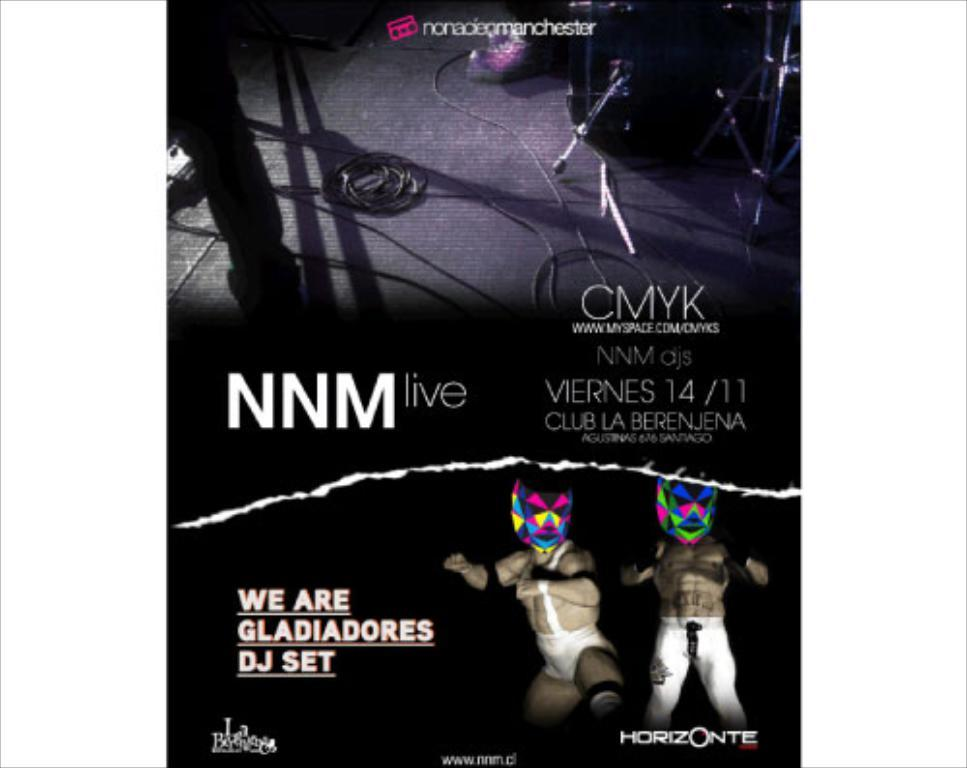What is featured in the picture? There is a poster in the picture. Can you describe the poster? The poster has two persons on the bottom right side. What are the persons on the poster wearing on their faces? The persons on the poster have masks on their faces. What else can be seen on the floor in the image? There appear to be cables on the floor in the image. What type of knowledge is being taught in the class depicted on the poster? There is no class depicted on the poster, as it only features two persons with masks on their faces. The poster does not show any indication of a class or any teaching activity; it is not possible to determine what type of knowledge is being taught from the image. 